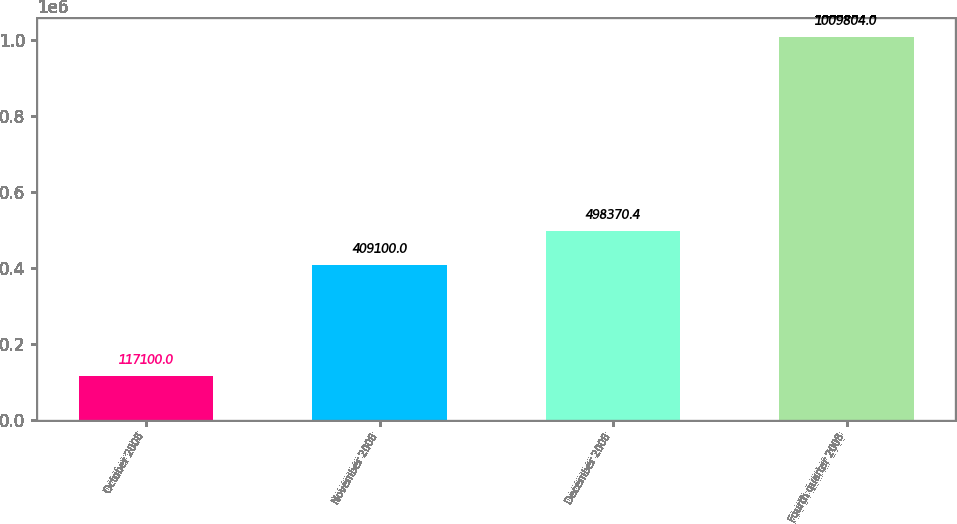Convert chart. <chart><loc_0><loc_0><loc_500><loc_500><bar_chart><fcel>October 2008<fcel>November 2008<fcel>December 2008<fcel>Fourth quarter 2008<nl><fcel>117100<fcel>409100<fcel>498370<fcel>1.0098e+06<nl></chart> 